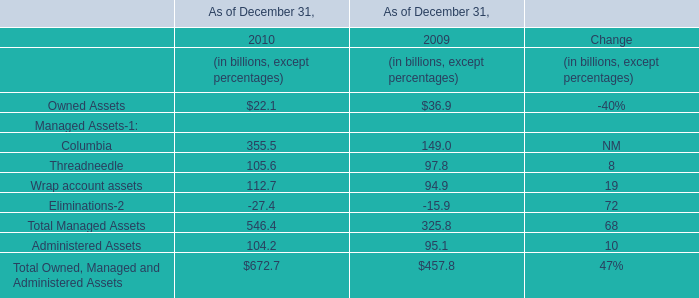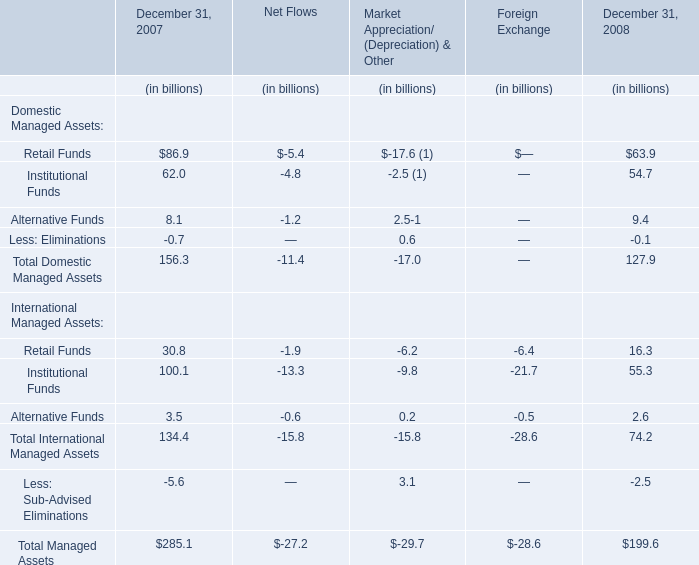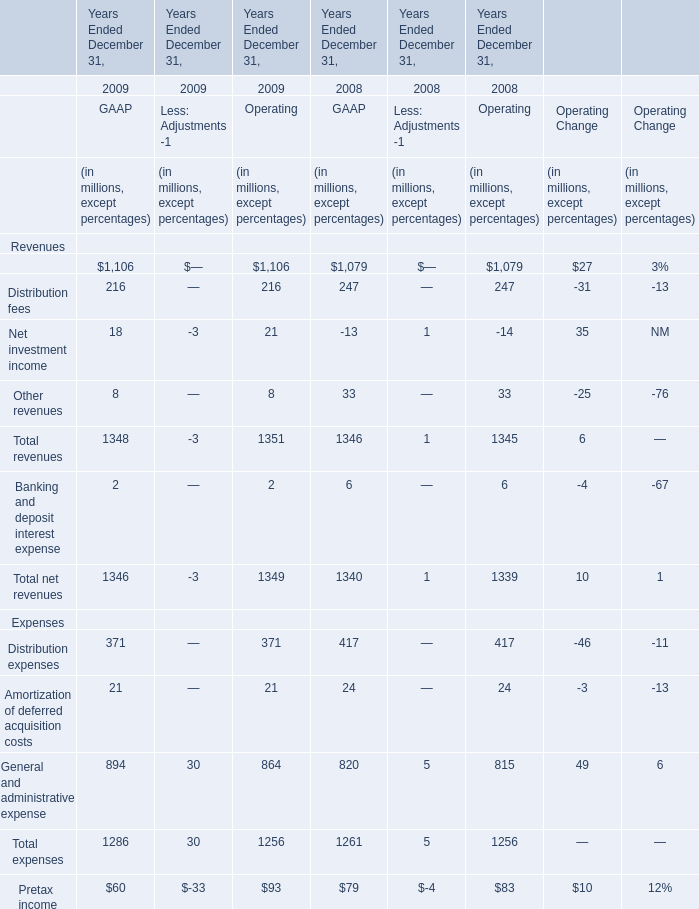What is the growing rate of Retail Funds in the year with the most Distribution fees for GAAP? 
Computations: ((16.3 - 30.8) / 30.8)
Answer: -0.47078. 